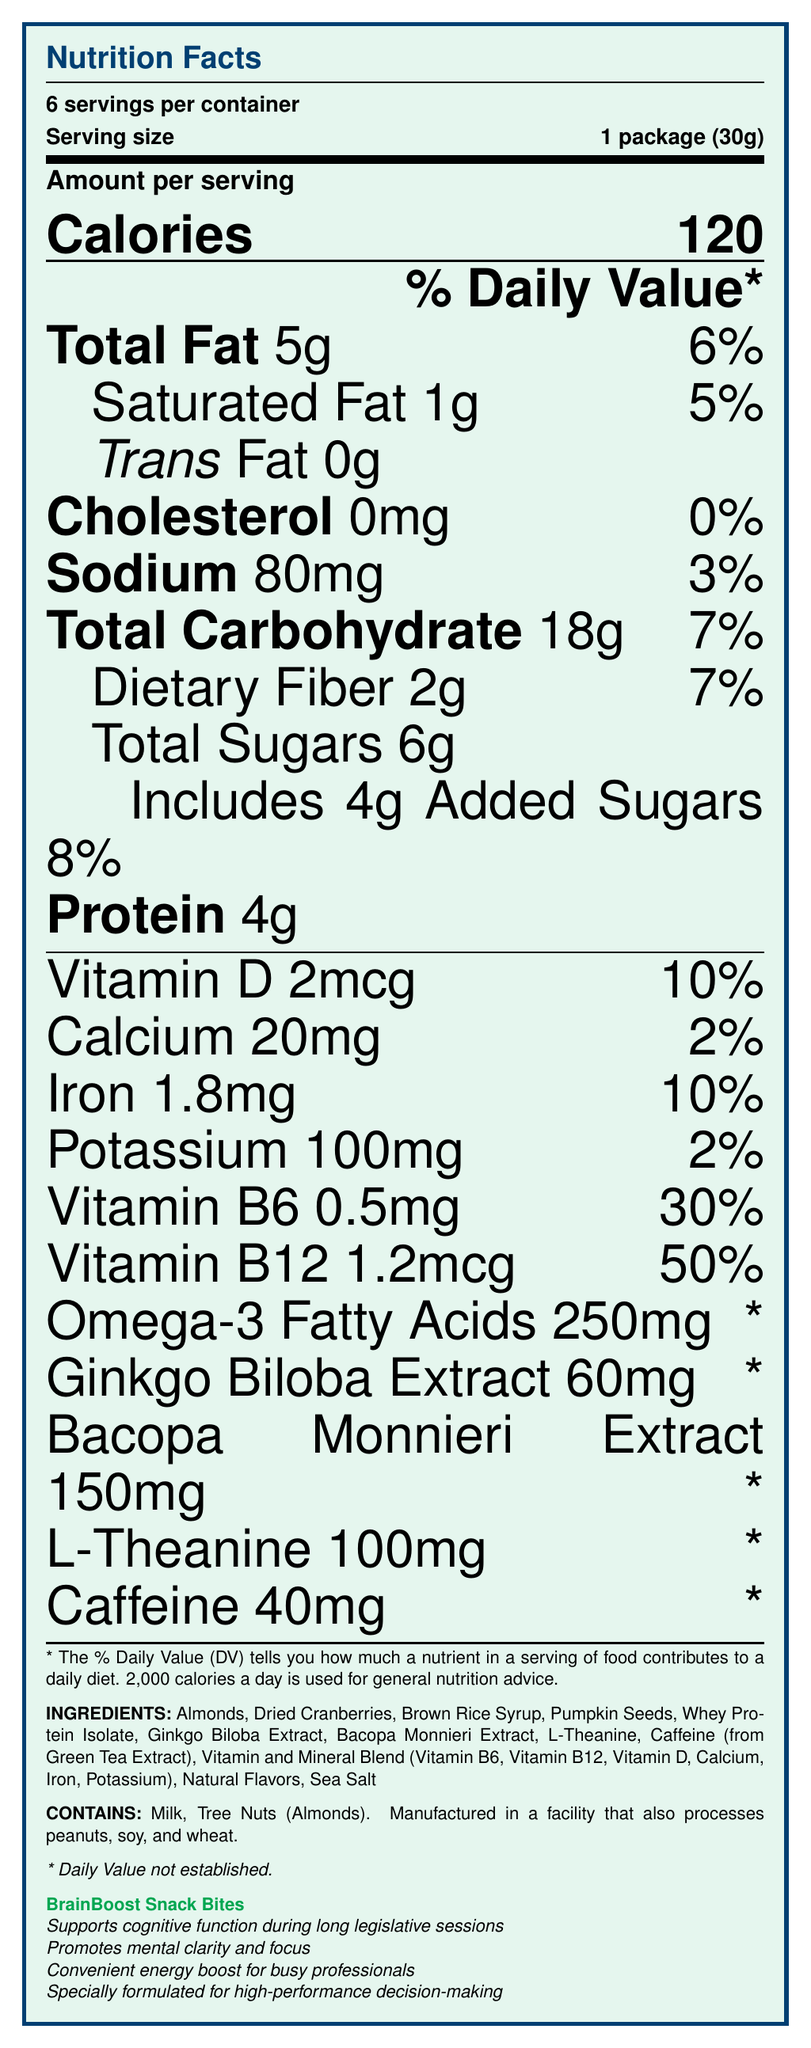What is the main idea of the document? The document describes the nutritional information, ingredients, marketing claims, and allergen information for a product called "BrainBoost Snack Bites" which is designed to support cognitive function during long legislative sessions.
Answer: BrainBoost Snack Bites What is the serving size of BrainBoost Snack Bites? The serving size is explicitly stated as "1 package (30g)."
Answer: 1 package (30g) How many calories are there per serving? The document shows "Calories 120" under the section for amount per serving.
Answer: 120 How much total fat is in each serving? The document lists "Total Fat 5g" under the nutrition facts.
Answer: 5g What percentage of the daily value of Vitamin B6 does one serving provide? The document lists "Vitamin B6 0.5mg 30%" under the nutrition facts.
Answer: 30% Does the product contain any tree nuts? The allergen information states "Contains: Milk, Tree Nuts (Almonds)."
Answer: Yes Which ingredient is a source of caffeine in the BrainBoost Snack Bites? The ingredients list includes "Caffeine (from Green Tea Extract)."
Answer: Caffeine (from Green Tea Extract) Which of the following nutrients does NOT have a daily value percentage established? A. Vitamin D B. Omega-3 Fatty Acids C. Iron D. Caffeine The document marks Omega-3 Fatty Acids with a "* Daily Value not established."
Answer: B. Omega-3 Fatty Acids What are the added sugars per serving? A. 2g B. 4g C. 6g D. 0g The document mentions "Includes 4g Added Sugars 8%."
Answer: B. 4g Is the product free of cholesterol? The document lists "Cholesterol 0mg 0%," indicating that it is free of cholesterol.
Answer: Yes Briefly describe the marketing claims made about BrainBoost Snack Bites. The document lists multiple marketing claims: "Supports cognitive function during long legislative sessions," "Promotes mental clarity and focus," "Convenient energy boost for busy professionals," and "Specially formulated for high-performance decision-making."
Answer: Supports cognitive function, promotes mental clarity, convenient energy boost, and is formulated for high-performance decision-making. How much iron does each serving contain in milligrams? The document specifies "Iron 1.8mg 10%" under the nutrition facts.
Answer: 1.8mg What is the total carbohydrate content per serving? The document states "Total Carbohydrate 18g 7%" under the nutrition facts.
Answer: 18g How much protein is in each serving? The document lists "Protein 4g" under the nutrition facts.
Answer: 4g What does the asterisk (*) next to the daily value percentages indicate? The document includes a note explaining that "*" indicates the daily value has not been established.
Answer: * Daily Value not established. Does BrainBoost Snack Bites meet FDA guidelines for fortified snack foods? The document states "Meets FDA guidelines for fortified snack foods."
Answer: Yes How much bacopa monnieri extract is included in each serving? Bacopa Monnieri Extract 150mg is listed under the nutrition facts with an asterisk indicating that the daily value is not established.
Answer: 150mg What is the daily value percentage for sodium in one package? The document lists "Sodium 80mg 3%" under the nutrition facts.
Answer: 3% Can the document provide information on whether the BrainBoost Snack Bites is gluten-free? The document does not provide explicit information regarding whether the product is gluten-free. It only mentions allergen information related to milk, tree nuts, peanuts, soy, and wheat.
Answer: Not enough information 